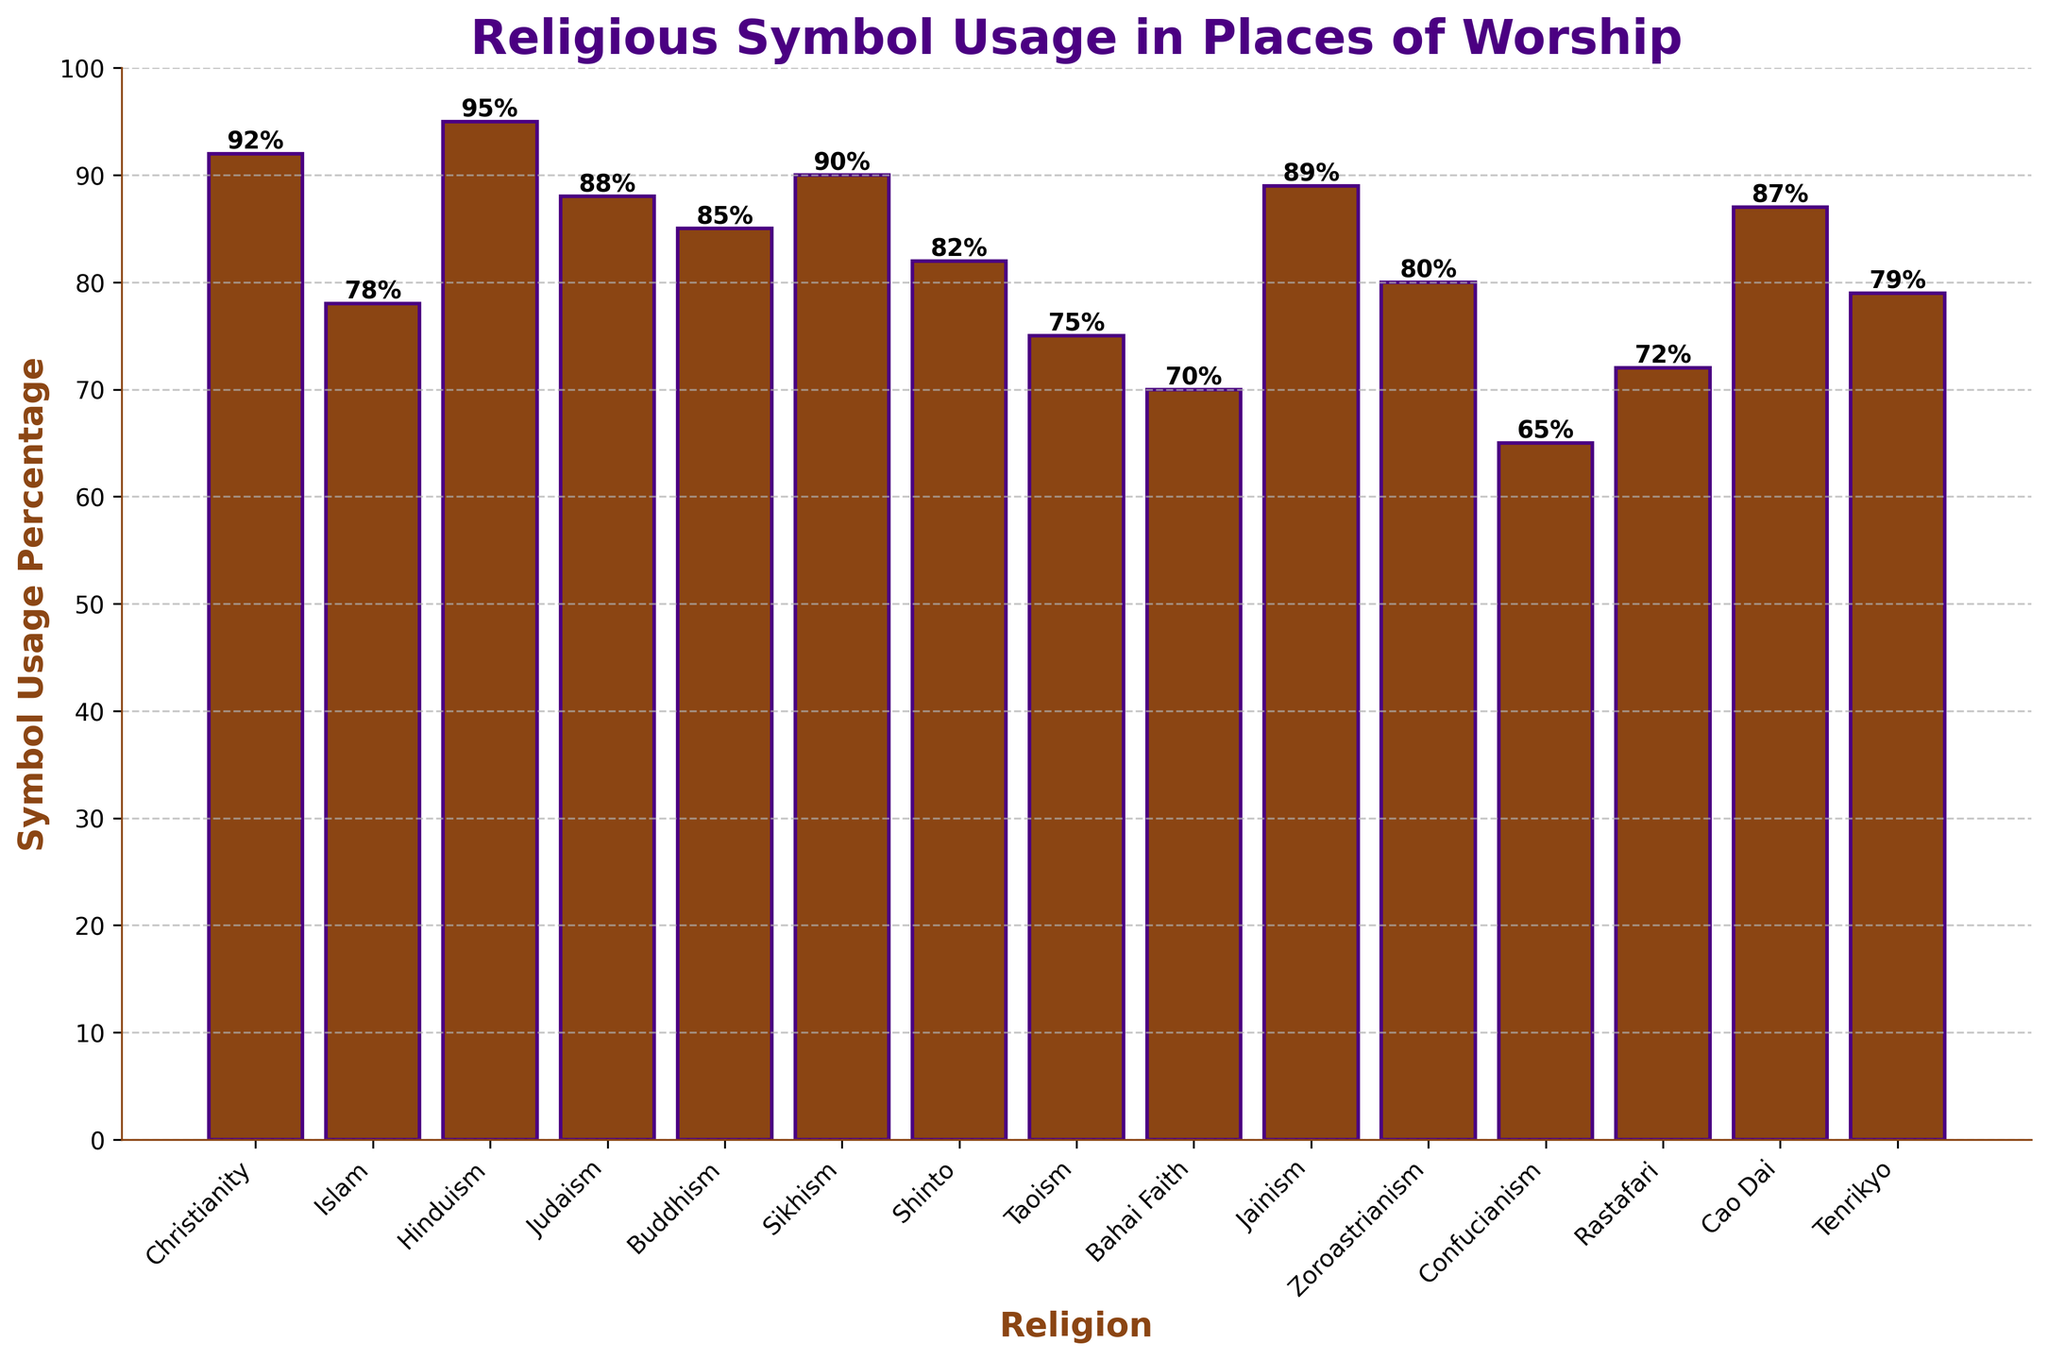Which religion has the highest symbol usage percentage? Step-by-step, scan through each bar in the chart and look at the height of the bars to find the tallest. The bar representing Hinduism is the tallest at 95%.
Answer: Hinduism Which religion uses sacred symbols the least in their places of worship? Look for the shortest bar, which corresponds to Confucianism at 65%.
Answer: Confucianism How much more is the symbol usage percentage in Christianity compared to Bahai Faith? Find the heights of the bars for Christianity (92%) and Bahai Faith (70%). Subtract 70% from 92% to find the difference (92% - 70% = 22%).
Answer: 22% Which religions have a symbol usage percentage greater than 80%? Identify all bars with heights greater than 80%. These include Christianity (92%), Islam (78%, not included), Hinduism (95%), Judaism (88%), Buddhism (85%), Sikhism (90%), Shinto (82%), Jainism (89%), Zoroastrianism (80%, not included), and Cao Dai (87%).
Answer: Christianity, Hinduism, Judaism, Buddhism, Sikhism, Shinto, Jainism, Cao Dai What is the average symbol usage percentage among the listed religions? Add up the percentages for all religions (92 + 78 + 95 + 88 + 85 + 90 + 82 + 75 + 70 + 89 + 80 + 65 + 72 + 87 + 79 = 1227). Divide by the number of religions (15) to get the average (1227/15 ≈ 81.8).
Answer: 81.8% Does Islam or Zoroastrianism have a higher symbol usage percentage? Compare the heights of the bars for Islam (78%) and Zoroastrianism (80%). Zoroastrianism has a higher percentage.
Answer: Zoroastrianism Which religion has a symbol usage percentage closest to 75%? Find the bar heights closest to 75%. Both Taoism and Tenrikyo have percentages near 75%, but Tenrikyo is at 79% and closer than Taoism at 75%.
Answer: Taoism What is the median symbol usage percentage of the listed religions? Arrange the symbol usage percentages in ascending order: 65, 70, 72, 75, 78, 79, 80, 82, 85, 87, 88, 89, 90, 92, 95. The median is the 8th number in this 15-number list, which is 82%.
Answer: 82% 